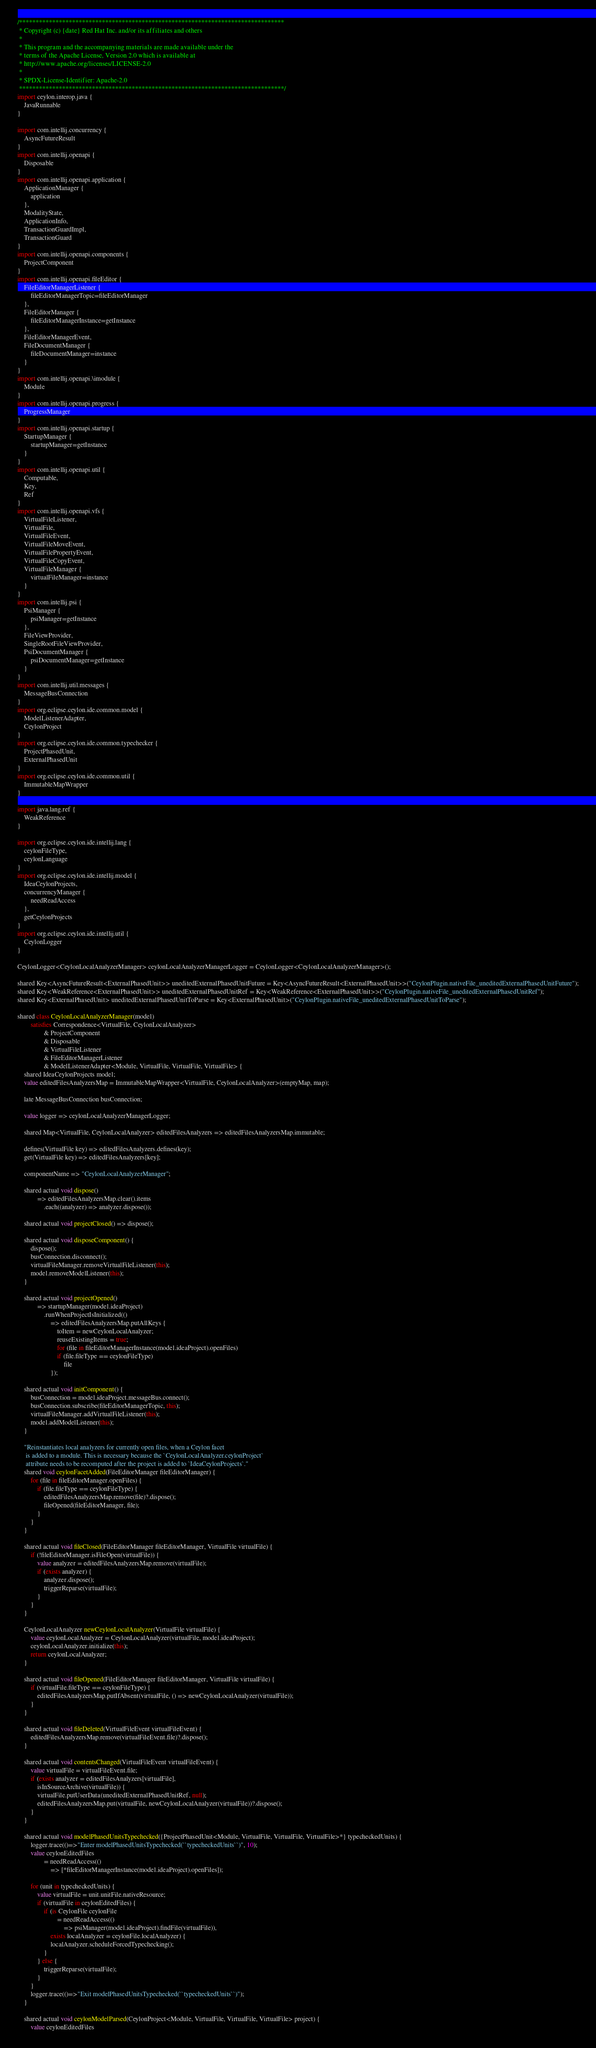Convert code to text. <code><loc_0><loc_0><loc_500><loc_500><_Ceylon_>/********************************************************************************
 * Copyright (c) {date} Red Hat Inc. and/or its affiliates and others
 *
 * This program and the accompanying materials are made available under the 
 * terms of the Apache License, Version 2.0 which is available at
 * http://www.apache.org/licenses/LICENSE-2.0
 *
 * SPDX-License-Identifier: Apache-2.0 
 ********************************************************************************/
import ceylon.interop.java {
    JavaRunnable
}

import com.intellij.concurrency {
    AsyncFutureResult
}
import com.intellij.openapi {
    Disposable
}
import com.intellij.openapi.application {
    ApplicationManager {
        application
    },
    ModalityState,
    ApplicationInfo,
    TransactionGuardImpl,
    TransactionGuard
}
import com.intellij.openapi.components {
    ProjectComponent
}
import com.intellij.openapi.fileEditor {
    FileEditorManagerListener {
        fileEditorManagerTopic=fileEditorManager
    },
    FileEditorManager {
        fileEditorManagerInstance=getInstance
    },
    FileEditorManagerEvent,
    FileDocumentManager {
        fileDocumentManager=instance
    }
}
import com.intellij.openapi.\imodule {
    Module
}
import com.intellij.openapi.progress {
    ProgressManager
}
import com.intellij.openapi.startup {
    StartupManager {
        startupManager=getInstance
    }
}
import com.intellij.openapi.util {
    Computable,
    Key,
    Ref
}
import com.intellij.openapi.vfs {
    VirtualFileListener,
    VirtualFile,
    VirtualFileEvent,
    VirtualFileMoveEvent,
    VirtualFilePropertyEvent,
    VirtualFileCopyEvent,
    VirtualFileManager {
        virtualFileManager=instance
    }
}
import com.intellij.psi {
    PsiManager {
        psiManager=getInstance
    },
    FileViewProvider,
    SingleRootFileViewProvider,
    PsiDocumentManager {
        psiDocumentManager=getInstance
    }
}
import com.intellij.util.messages {
    MessageBusConnection
}
import org.eclipse.ceylon.ide.common.model {
    ModelListenerAdapter,
    CeylonProject
}
import org.eclipse.ceylon.ide.common.typechecker {
    ProjectPhasedUnit,
    ExternalPhasedUnit
}
import org.eclipse.ceylon.ide.common.util {
    ImmutableMapWrapper
}

import java.lang.ref {
    WeakReference
}

import org.eclipse.ceylon.ide.intellij.lang {
    ceylonFileType,
    ceylonLanguage
}
import org.eclipse.ceylon.ide.intellij.model {
    IdeaCeylonProjects,
    concurrencyManager {
        needReadAccess
    },
    getCeylonProjects
}
import org.eclipse.ceylon.ide.intellij.util {
    CeylonLogger
}

CeylonLogger<CeylonLocalAnalyzerManager> ceylonLocalAnalyzerManagerLogger = CeylonLogger<CeylonLocalAnalyzerManager>();

shared Key<AsyncFutureResult<ExternalPhasedUnit>> uneditedExternalPhasedUnitFuture = Key<AsyncFutureResult<ExternalPhasedUnit>>("CeylonPlugin.nativeFile_uneditedExternalPhasedUnitFuture");
shared Key<WeakReference<ExternalPhasedUnit>> uneditedExternalPhasedUnitRef = Key<WeakReference<ExternalPhasedUnit>>("CeylonPlugin.nativeFile_uneditedExternalPhasedUnitRef");
shared Key<ExternalPhasedUnit> uneditedExternalPhasedUnitToParse = Key<ExternalPhasedUnit>("CeylonPlugin.nativeFile_uneditedExternalPhasedUnitToParse");

shared class CeylonLocalAnalyzerManager(model) 
        satisfies Correspondence<VirtualFile, CeylonLocalAnalyzer>
                & ProjectComponent
                & Disposable
                & VirtualFileListener
                & FileEditorManagerListener
                & ModelListenerAdapter<Module, VirtualFile, VirtualFile, VirtualFile> {
    shared IdeaCeylonProjects model;    
    value editedFilesAnalyzersMap = ImmutableMapWrapper<VirtualFile, CeylonLocalAnalyzer>(emptyMap, map);
    
    late MessageBusConnection busConnection;

    value logger => ceylonLocalAnalyzerManagerLogger;
            
    shared Map<VirtualFile, CeylonLocalAnalyzer> editedFilesAnalyzers => editedFilesAnalyzersMap.immutable;

    defines(VirtualFile key) => editedFilesAnalyzers.defines(key);
    get(VirtualFile key) => editedFilesAnalyzers[key];

    componentName => "CeylonLocalAnalyzerManager";
    
    shared actual void dispose()
            => editedFilesAnalyzersMap.clear().items
                .each((analyzer) => analyzer.dispose());

    shared actual void projectClosed() => dispose();

    shared actual void disposeComponent() {
        dispose();
        busConnection.disconnect();
        virtualFileManager.removeVirtualFileListener(this);
        model.removeModelListener(this);
    }
    
    shared actual void projectOpened()
            => startupManager(model.ideaProject)
                .runWhenProjectIsInitialized(()
                    => editedFilesAnalyzersMap.putAllKeys {
                        toItem = newCeylonLocalAnalyzer;
                        reuseExistingItems = true;
                        for (file in fileEditorManagerInstance(model.ideaProject).openFiles)
                        if (file.fileType == ceylonFileType)
                            file
                    });

    shared actual void initComponent() {
        busConnection = model.ideaProject.messageBus.connect();
        busConnection.subscribe(fileEditorManagerTopic, this);
        virtualFileManager.addVirtualFileListener(this);
        model.addModelListener(this);
    }
    
    "Reinstantiates local analyzers for currently open files, when a Ceylon facet
     is added to a module. This is necessary because the `CeylonLocalAnalyzer.ceylonProject`
     attribute needs to be recomputed after the project is added to `IdeaCeylonProjects`."
    shared void ceylonFacetAdded(FileEditorManager fileEditorManager) {
        for (file in fileEditorManager.openFiles) {
            if (file.fileType == ceylonFileType) {
                editedFilesAnalyzersMap.remove(file)?.dispose();
                fileOpened(fileEditorManager, file);
            }
        }
    }
    
    shared actual void fileClosed(FileEditorManager fileEditorManager, VirtualFile virtualFile) {
        if (!fileEditorManager.isFileOpen(virtualFile)) {
            value analyzer = editedFilesAnalyzersMap.remove(virtualFile);
            if (exists analyzer) {
                analyzer.dispose();
                triggerReparse(virtualFile);
            }
        }
    }
    
    CeylonLocalAnalyzer newCeylonLocalAnalyzer(VirtualFile virtualFile) {
        value ceylonLocalAnalyzer = CeylonLocalAnalyzer(virtualFile, model.ideaProject);
        ceylonLocalAnalyzer.initialize(this);
        return ceylonLocalAnalyzer;
    }
    
    shared actual void fileOpened(FileEditorManager fileEditorManager, VirtualFile virtualFile) {
        if (virtualFile.fileType == ceylonFileType) {
            editedFilesAnalyzersMap.putIfAbsent(virtualFile, () => newCeylonLocalAnalyzer(virtualFile));
        }
    }
    
    shared actual void fileDeleted(VirtualFileEvent virtualFileEvent) {
        editedFilesAnalyzersMap.remove(virtualFileEvent.file)?.dispose();
    }

    shared actual void contentsChanged(VirtualFileEvent virtualFileEvent) {
        value virtualFile = virtualFileEvent.file;
        if (exists analyzer = editedFilesAnalyzers[virtualFile],
            isInSourceArchive(virtualFile)) {
            virtualFile.putUserData(uneditedExternalPhasedUnitRef, null);
            editedFilesAnalyzersMap.put(virtualFile, newCeylonLocalAnalyzer(virtualFile))?.dispose();
        }
    }

    shared actual void modelPhasedUnitsTypechecked({ProjectPhasedUnit<Module, VirtualFile, VirtualFile, VirtualFile>*} typecheckedUnits) {
        logger.trace(()=>"Enter modelPhasedUnitsTypechecked(``typecheckedUnits``)", 10);
        value ceylonEditedFiles
                = needReadAccess(()
                    => [*fileEditorManagerInstance(model.ideaProject).openFiles]);

        for (unit in typecheckedUnits) {
            value virtualFile = unit.unitFile.nativeResource;
            if (virtualFile in ceylonEditedFiles) {
                if (is CeylonFile ceylonFile
                        = needReadAccess(()
                            => psiManager(model.ideaProject).findFile(virtualFile)),
                    exists localAnalyzer = ceylonFile.localAnalyzer) {
                    localAnalyzer.scheduleForcedTypechecking();
                }
            } else {
                triggerReparse(virtualFile);
            }
        }
        logger.trace(()=>"Exit modelPhasedUnitsTypechecked(``typecheckedUnits``)");
    }

    shared actual void ceylonModelParsed(CeylonProject<Module, VirtualFile, VirtualFile, VirtualFile> project) {
        value ceylonEditedFiles</code> 